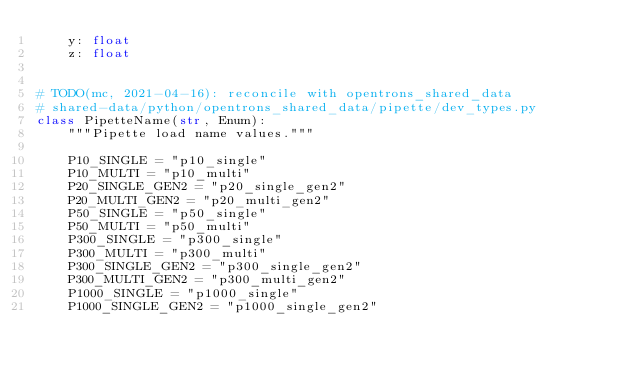Convert code to text. <code><loc_0><loc_0><loc_500><loc_500><_Python_>    y: float
    z: float


# TODO(mc, 2021-04-16): reconcile with opentrons_shared_data
# shared-data/python/opentrons_shared_data/pipette/dev_types.py
class PipetteName(str, Enum):
    """Pipette load name values."""

    P10_SINGLE = "p10_single"
    P10_MULTI = "p10_multi"
    P20_SINGLE_GEN2 = "p20_single_gen2"
    P20_MULTI_GEN2 = "p20_multi_gen2"
    P50_SINGLE = "p50_single"
    P50_MULTI = "p50_multi"
    P300_SINGLE = "p300_single"
    P300_MULTI = "p300_multi"
    P300_SINGLE_GEN2 = "p300_single_gen2"
    P300_MULTI_GEN2 = "p300_multi_gen2"
    P1000_SINGLE = "p1000_single"
    P1000_SINGLE_GEN2 = "p1000_single_gen2"
</code> 